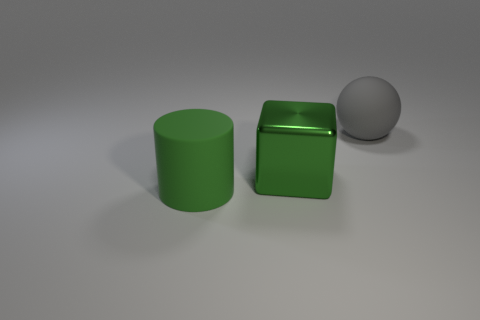What does the color scheme in this image suggest about the intended atmosphere or setting? The color scheme, with its neutral background and uniform green color for the cylinder and cube, suggests a minimalist or controlled atmosphere. It may be designed to evoke a sense of order and simplicity, possibly for a setting that values modern design principles. 